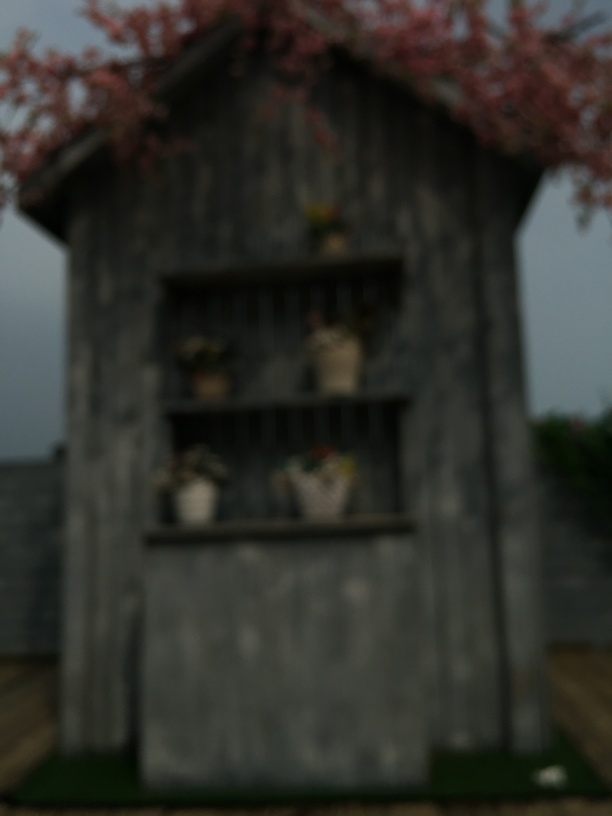What improvements could be made to this image? To enhance the quality of this image, adjusting the focus to make it sharper and ensuring proper lighting would greatly improve clarity and allow for a better appreciation of the subject matter presented. 